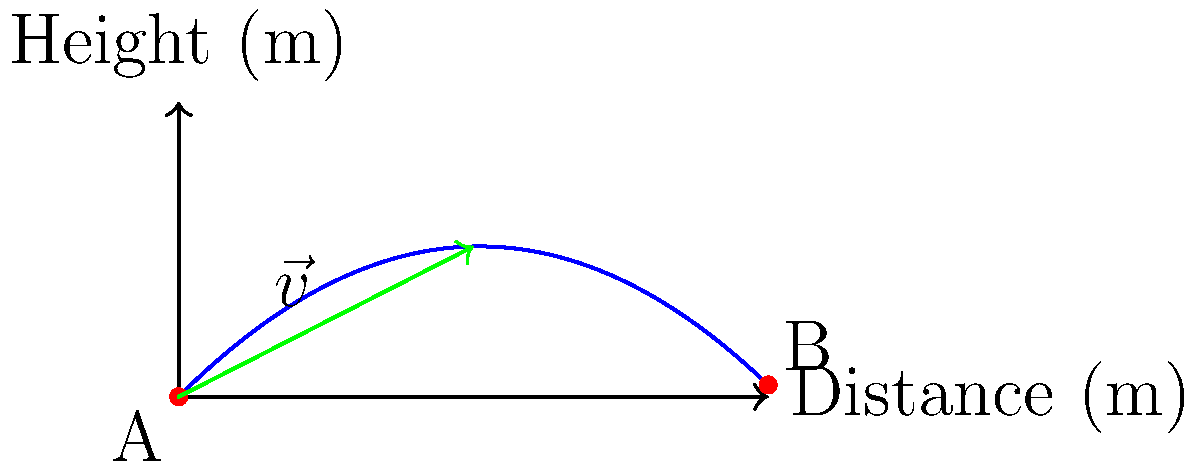At your tailgating event before a big Texas A&M game, a quarterback throws a football from point A to point B. The initial velocity of the football is 20 m/s at a 45-degree angle. Assuming no air resistance, what is the magnitude of the displacement vector $\vec{v}$ (in meters) when the football reaches its maximum height? Let's approach this step-by-step:

1) First, we need to find the time it takes for the football to reach its maximum height. At this point, the vertical component of velocity is zero.

2) The vertical component of initial velocity is:
   $v_{0y} = v_0 \sin \theta = 20 \sin 45° = 20 \cdot \frac{\sqrt{2}}{2} \approx 14.14$ m/s

3) Using the equation $v_y = v_{0y} - gt$, where $g = 9.8$ m/s², we can find the time:
   $0 = 14.14 - 9.8t$
   $t = \frac{14.14}{9.8} \approx 1.44$ seconds

4) Now, we can find the horizontal distance traveled in this time:
   $x = v_{0x}t = (v_0 \cos \theta)t = (20 \cos 45°)(1.44) = 20 \cdot \frac{\sqrt{2}}{2} \cdot 1.44 \approx 20.41$ m

5) The vertical displacement at maximum height is:
   $y = v_{0y}t - \frac{1}{2}gt^2 = 14.14 \cdot 1.44 - \frac{1}{2} \cdot 9.8 \cdot 1.44^2 \approx 10.20$ m

6) The displacement vector $\vec{v}$ is therefore $(20.41, 10.20)$.

7) The magnitude of this vector is:
   $|\vec{v}| = \sqrt{20.41^2 + 10.20^2} \approx 22.82$ m
Answer: 22.82 m 